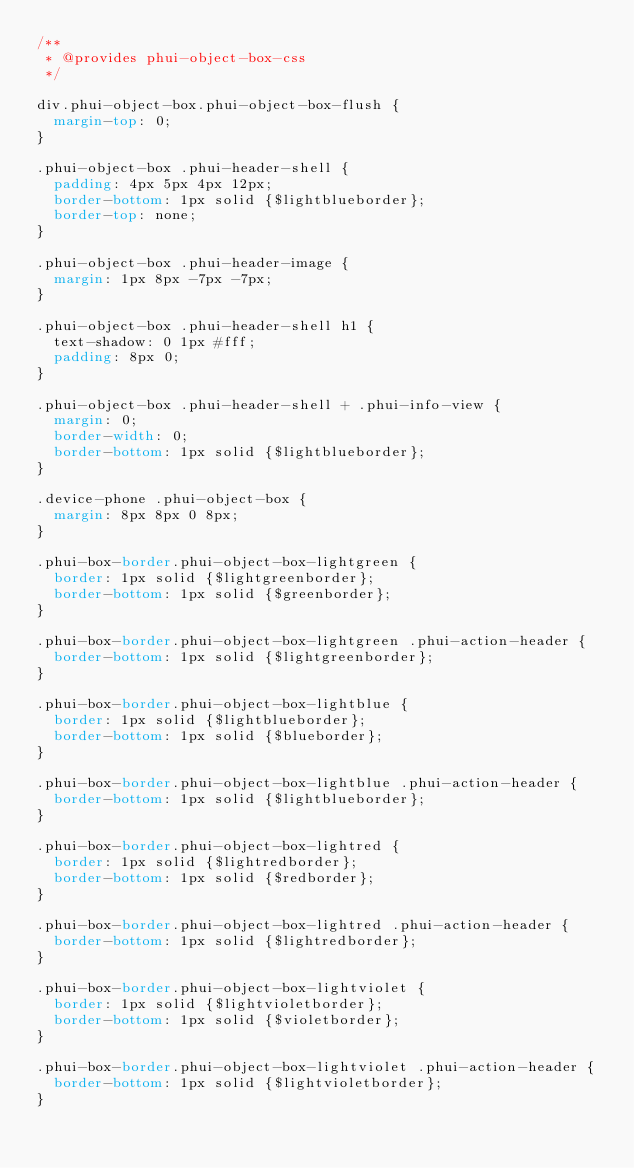Convert code to text. <code><loc_0><loc_0><loc_500><loc_500><_CSS_>/**
 * @provides phui-object-box-css
 */

div.phui-object-box.phui-object-box-flush {
  margin-top: 0;
}

.phui-object-box .phui-header-shell {
  padding: 4px 5px 4px 12px;
  border-bottom: 1px solid {$lightblueborder};
  border-top: none;
}

.phui-object-box .phui-header-image {
  margin: 1px 8px -7px -7px;
}

.phui-object-box .phui-header-shell h1 {
  text-shadow: 0 1px #fff;
  padding: 8px 0;
}

.phui-object-box .phui-header-shell + .phui-info-view {
  margin: 0;
  border-width: 0;
  border-bottom: 1px solid {$lightblueborder};
}

.device-phone .phui-object-box {
  margin: 8px 8px 0 8px;
}

.phui-box-border.phui-object-box-lightgreen {
  border: 1px solid {$lightgreenborder};
  border-bottom: 1px solid {$greenborder};
}

.phui-box-border.phui-object-box-lightgreen .phui-action-header {
  border-bottom: 1px solid {$lightgreenborder};
}

.phui-box-border.phui-object-box-lightblue {
  border: 1px solid {$lightblueborder};
  border-bottom: 1px solid {$blueborder};
}

.phui-box-border.phui-object-box-lightblue .phui-action-header {
  border-bottom: 1px solid {$lightblueborder};
}

.phui-box-border.phui-object-box-lightred {
  border: 1px solid {$lightredborder};
  border-bottom: 1px solid {$redborder};
}

.phui-box-border.phui-object-box-lightred .phui-action-header {
  border-bottom: 1px solid {$lightredborder};
}

.phui-box-border.phui-object-box-lightviolet {
  border: 1px solid {$lightvioletborder};
  border-bottom: 1px solid {$violetborder};
}

.phui-box-border.phui-object-box-lightviolet .phui-action-header {
  border-bottom: 1px solid {$lightvioletborder};
}
</code> 